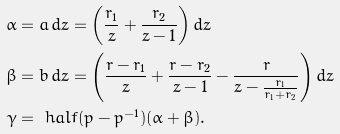Convert formula to latex. <formula><loc_0><loc_0><loc_500><loc_500>\alpha & = a \, d z = \left ( \frac { r _ { 1 } } { z } + \frac { r _ { 2 } } { z - 1 } \right ) d z \\ \beta & = b \, d z = \left ( \frac { r - r _ { 1 } } { z } + \frac { r - r _ { 2 } } { z - 1 } - \frac { r } { z - \frac { r _ { 1 } } { r _ { 1 } + r _ { 2 } } } \right ) d z \\ \gamma & = \ h a l f ( p - p ^ { - 1 } ) ( \alpha + \beta ) .</formula> 